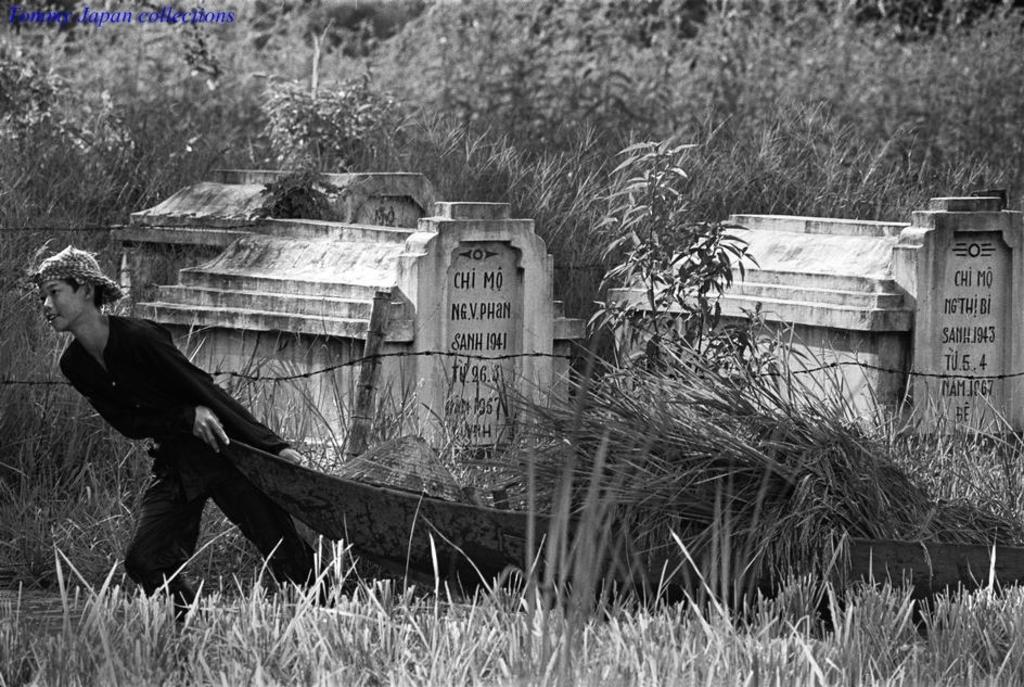What is the color scheme of the image? The image is in black and white. Who or what can be seen in the image? There is a boy in the image. What is the boy doing in the image? The boy is dragging something on the ground. What type of natural environment is visible in the image? There is grass and plants visible in the image. What type of structure can be seen in the image? There are tombstones with fencing in the image. What type of pollution can be seen in the image? There is no pollution visible in the image. Whose bedroom is shown in the image? The image does not depict a bedroom. 